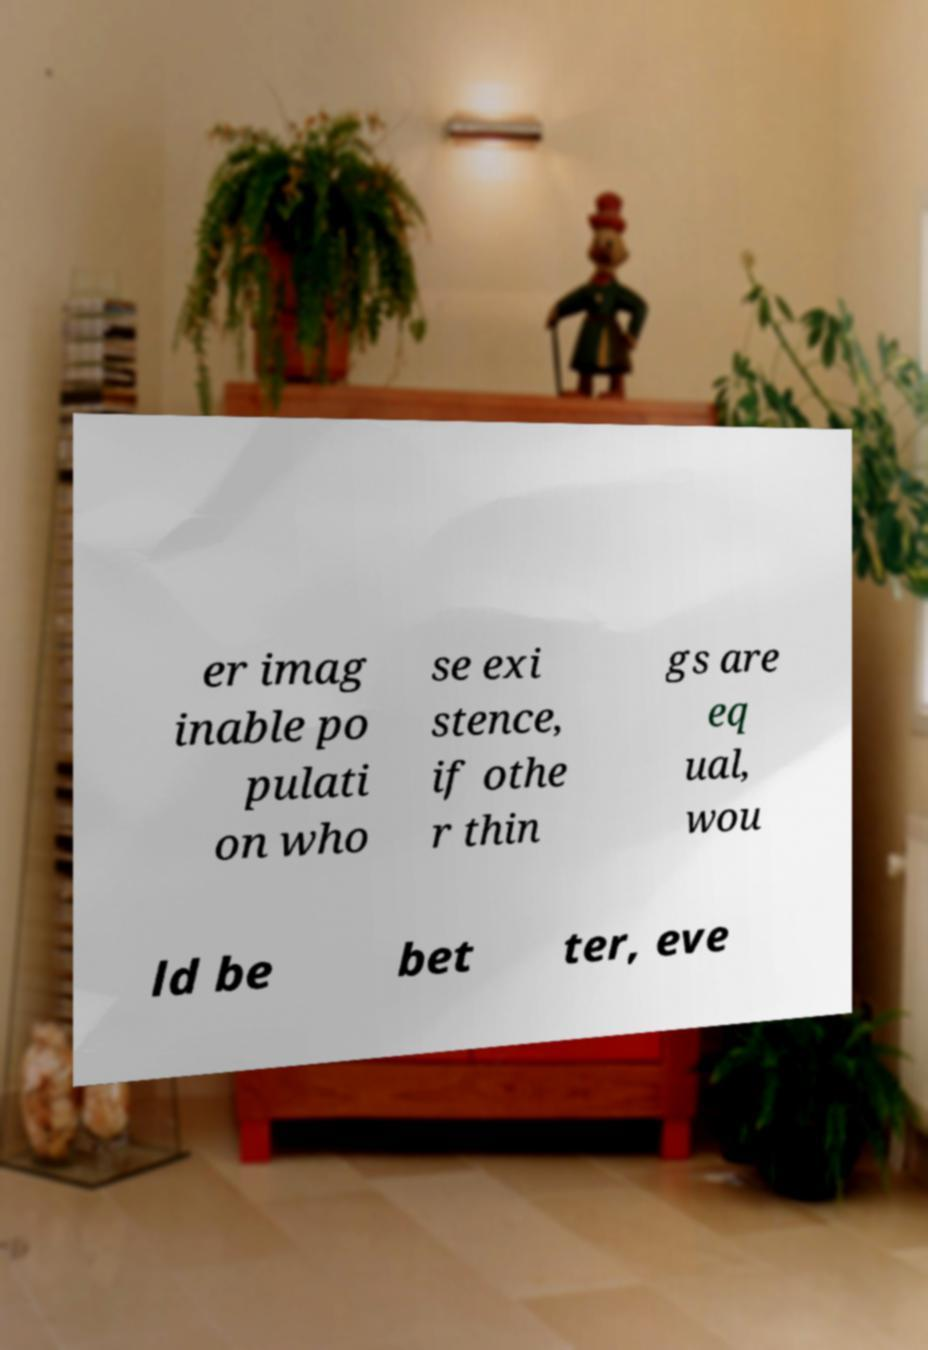Could you extract and type out the text from this image? er imag inable po pulati on who se exi stence, if othe r thin gs are eq ual, wou ld be bet ter, eve 